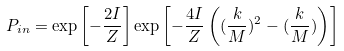<formula> <loc_0><loc_0><loc_500><loc_500>P _ { i n } = \exp \left [ - \frac { 2 I } { Z } \right ] \exp \left [ - \frac { 4 I } { Z } \left ( ( \frac { k } { M } ) ^ { 2 } - ( \frac { k } { M } ) \right ) \right ]</formula> 